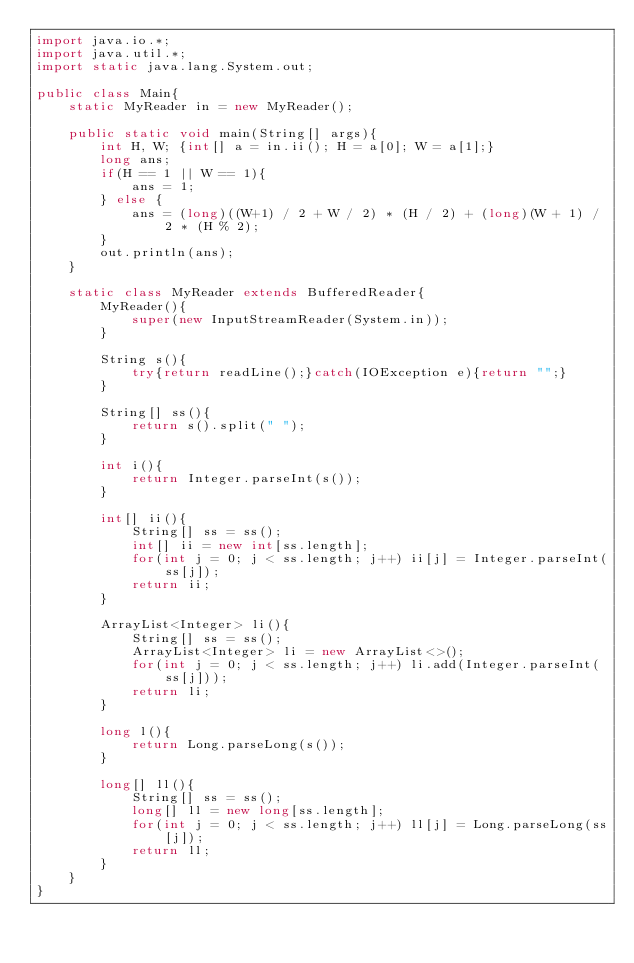Convert code to text. <code><loc_0><loc_0><loc_500><loc_500><_Java_>import java.io.*;
import java.util.*;
import static java.lang.System.out;

public class Main{
    static MyReader in = new MyReader();

    public static void main(String[] args){
        int H, W; {int[] a = in.ii(); H = a[0]; W = a[1];}
        long ans;
        if(H == 1 || W == 1){
            ans = 1;
        } else {
            ans = (long)((W+1) / 2 + W / 2) * (H / 2) + (long)(W + 1) / 2 * (H % 2);
        }
        out.println(ans);
    }

    static class MyReader extends BufferedReader{
        MyReader(){
            super(new InputStreamReader(System.in));
        }

        String s(){
            try{return readLine();}catch(IOException e){return "";}
        }

        String[] ss(){
            return s().split(" ");
        }

        int i(){
            return Integer.parseInt(s());
        }

        int[] ii(){
            String[] ss = ss();
            int[] ii = new int[ss.length];
            for(int j = 0; j < ss.length; j++) ii[j] = Integer.parseInt(ss[j]);
            return ii;
        }

        ArrayList<Integer> li(){
            String[] ss = ss();
            ArrayList<Integer> li = new ArrayList<>();
            for(int j = 0; j < ss.length; j++) li.add(Integer.parseInt(ss[j]));
            return li;
        }

        long l(){
            return Long.parseLong(s());
        }

        long[] ll(){
            String[] ss = ss();
            long[] ll = new long[ss.length];
            for(int j = 0; j < ss.length; j++) ll[j] = Long.parseLong(ss[j]);
            return ll;
        }
    }
}
</code> 